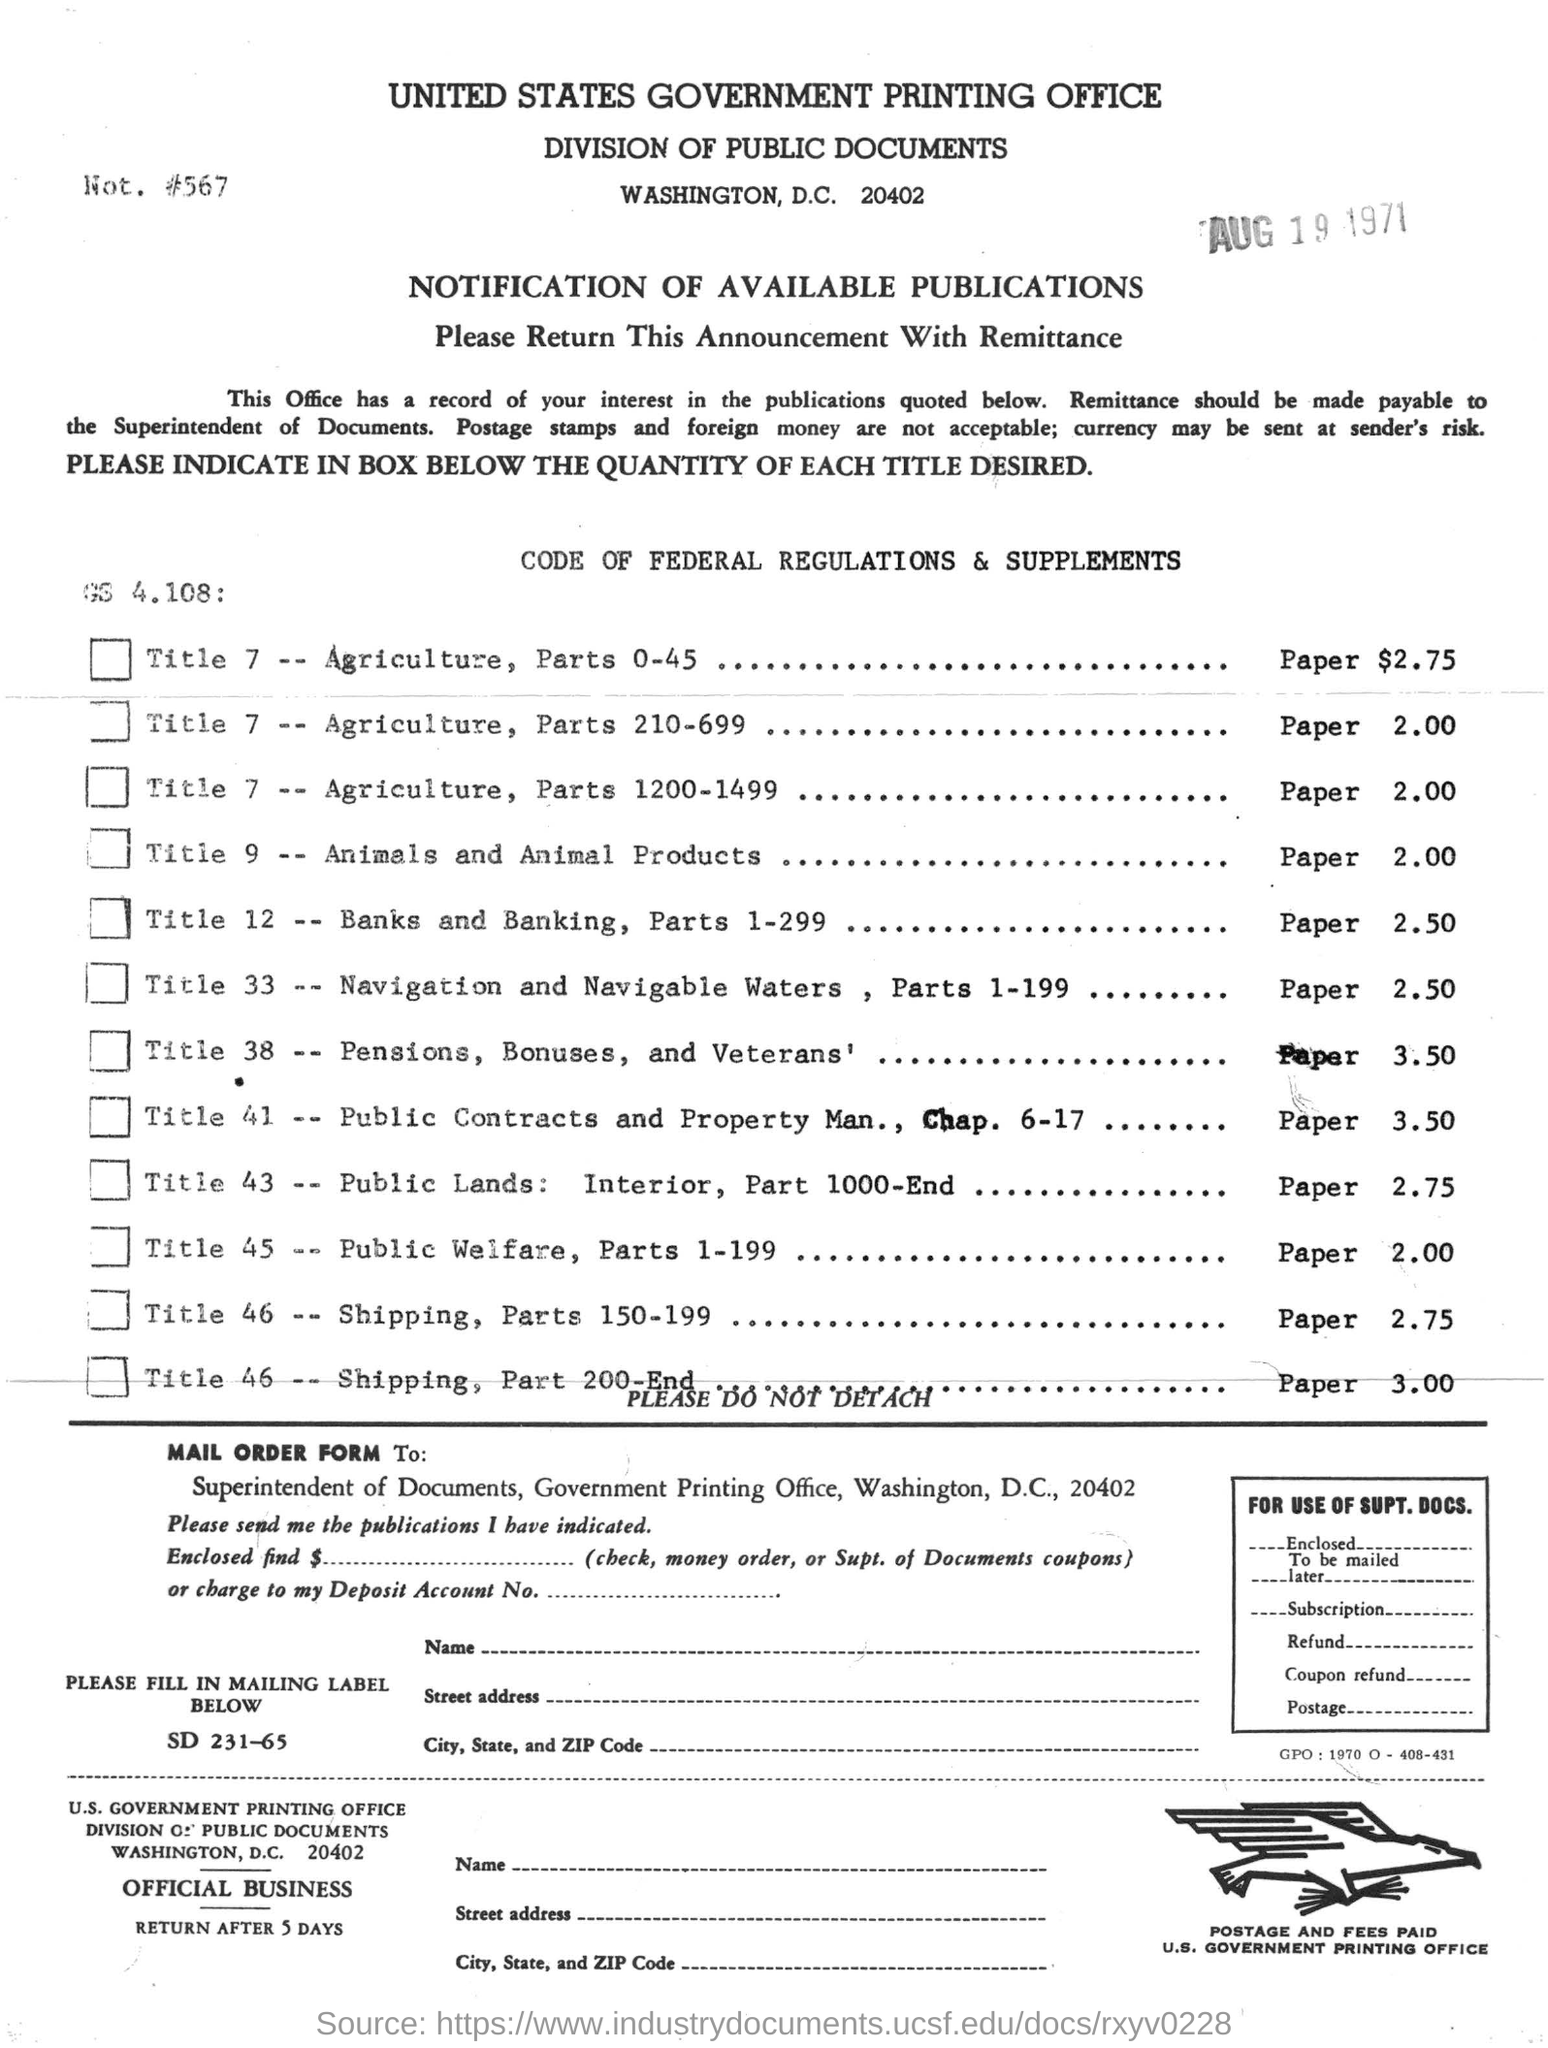Which government printing office it is?
Make the answer very short. United states government printing office. In which city united states government printing office is located?
Make the answer very short. WASHINGTON, D.C. For which title animal and animal products are sold for paper $2.00?
Your answer should be very brief. Title 9. What is the date-stamp in the document?
Offer a terse response. Aug 19 1971. 